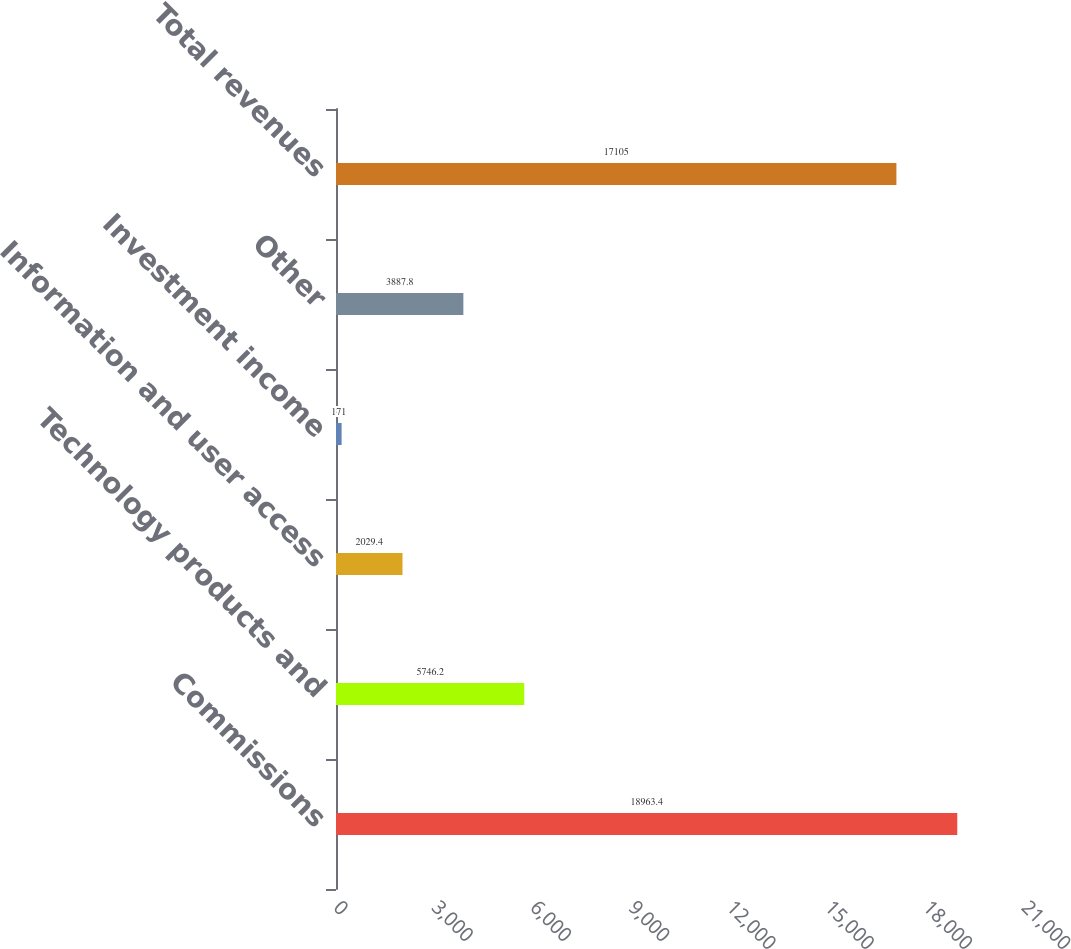Convert chart to OTSL. <chart><loc_0><loc_0><loc_500><loc_500><bar_chart><fcel>Commissions<fcel>Technology products and<fcel>Information and user access<fcel>Investment income<fcel>Other<fcel>Total revenues<nl><fcel>18963.4<fcel>5746.2<fcel>2029.4<fcel>171<fcel>3887.8<fcel>17105<nl></chart> 